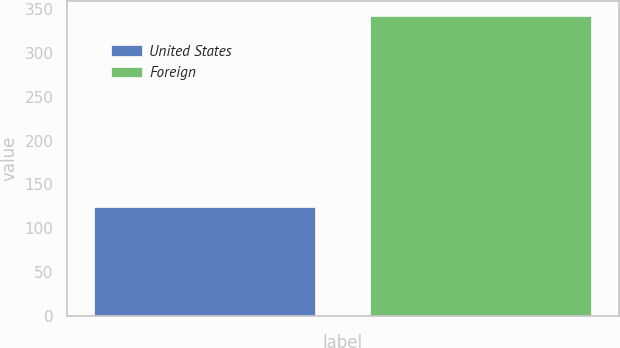Convert chart to OTSL. <chart><loc_0><loc_0><loc_500><loc_500><bar_chart><fcel>United States<fcel>Foreign<nl><fcel>124<fcel>343<nl></chart> 